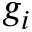Convert formula to latex. <formula><loc_0><loc_0><loc_500><loc_500>g _ { i }</formula> 